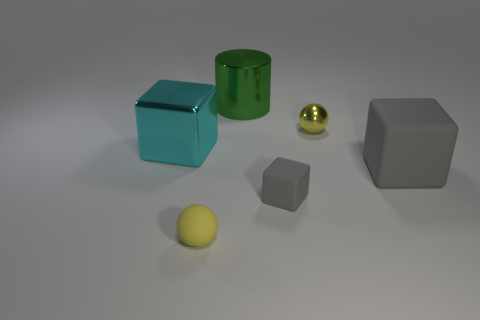Are there an equal number of gray rubber blocks to the right of the tiny gray block and big green cylinders that are right of the green metallic thing?
Provide a short and direct response. No. What is the color of the small object that is the same material as the green cylinder?
Keep it short and to the point. Yellow. Are there any small gray objects made of the same material as the green cylinder?
Make the answer very short. No. What number of objects are either small yellow metallic cylinders or yellow objects?
Offer a terse response. 2. Is the big cyan block made of the same material as the small yellow sphere right of the green metallic cylinder?
Your answer should be compact. Yes. What size is the gray matte thing on the left side of the tiny shiny ball?
Your answer should be compact. Small. Are there fewer small yellow metal objects than large yellow metallic cylinders?
Your answer should be compact. No. Is there a matte object that has the same color as the small shiny sphere?
Provide a succinct answer. Yes. What shape is the thing that is behind the small rubber block and in front of the large cyan thing?
Keep it short and to the point. Cube. There is a tiny yellow thing in front of the large cube on the left side of the tiny yellow rubber thing; what shape is it?
Make the answer very short. Sphere. 